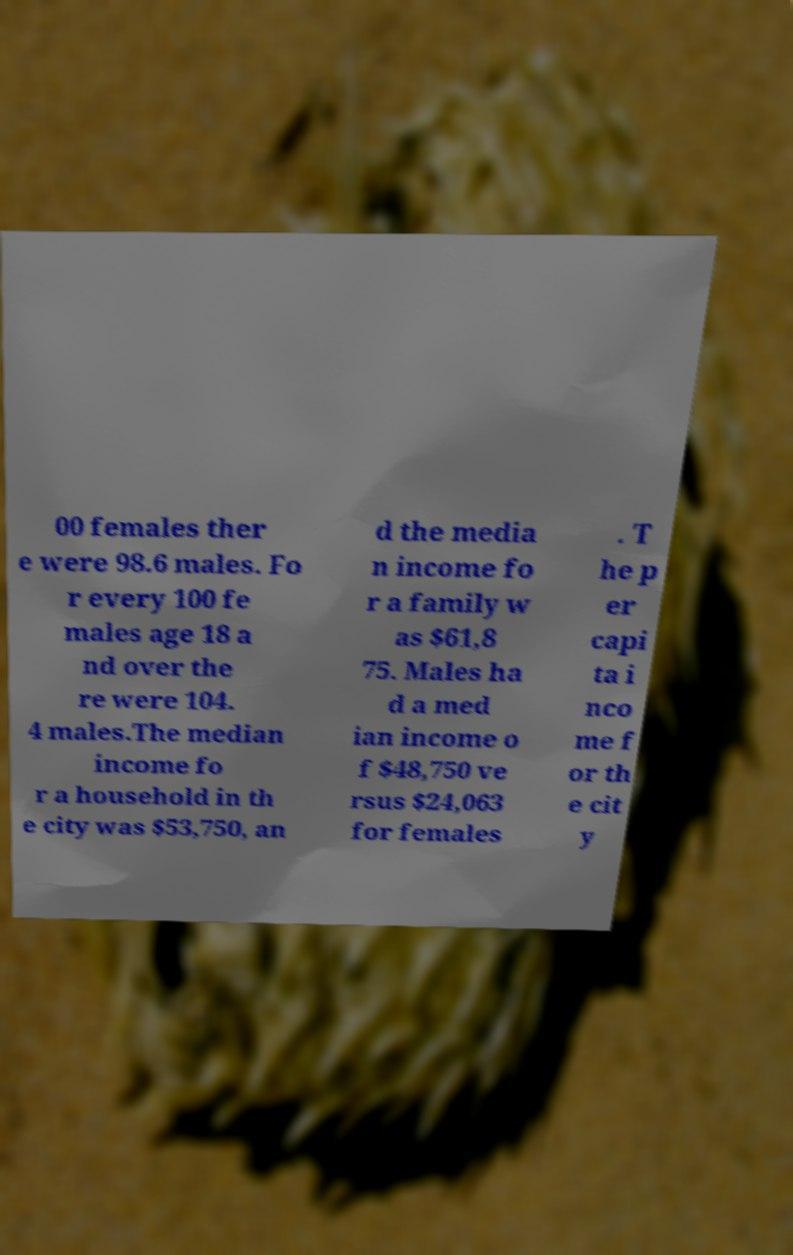Can you read and provide the text displayed in the image?This photo seems to have some interesting text. Can you extract and type it out for me? 00 females ther e were 98.6 males. Fo r every 100 fe males age 18 a nd over the re were 104. 4 males.The median income fo r a household in th e city was $53,750, an d the media n income fo r a family w as $61,8 75. Males ha d a med ian income o f $48,750 ve rsus $24,063 for females . T he p er capi ta i nco me f or th e cit y 